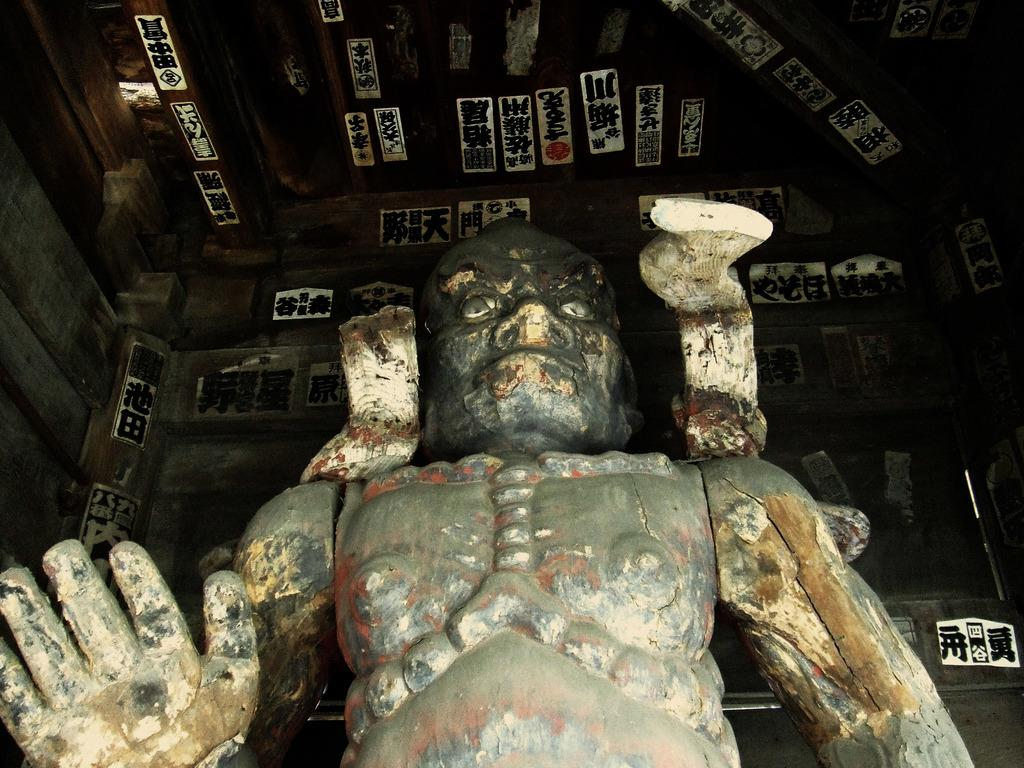What is the main subject of the image? There is a statue of a man in the image. What can be seen above the statue? There is a roof visible in the image. What is attached to the roof? Paintings are attached to the roof. What type of shoe is hanging from the branch in the image? There is no branch or shoe present in the image. 